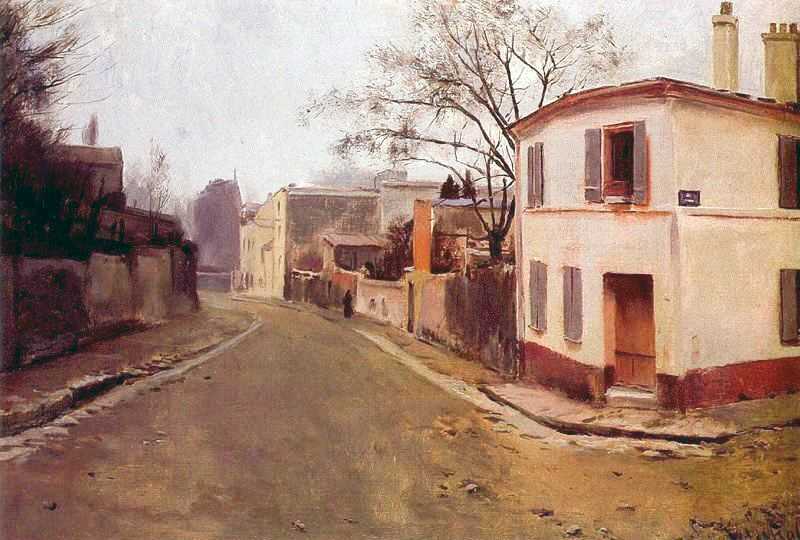Imagine a story set in this street. What era is it, and who are the main characters? The story is set in the early 1900s in a quaint, tranquil town. The main characters are Clara, a young schoolteacher who recently moved to the town, and Mr. Thompson, an elderly retired musician who has lived there his entire life. Clara is curious about the town's history and often finds herself walking down this peaceful street after school, admiring the architecture and serene atmosphere. Mr. Thompson enjoys sitting on his porch, playing his old violin as Clara walks by. They gradually form a friendship through their shared love of history and music. Clara learns about the town's past through Mr. Thompson's stories, while her presence brings new life and energy to the old town. 